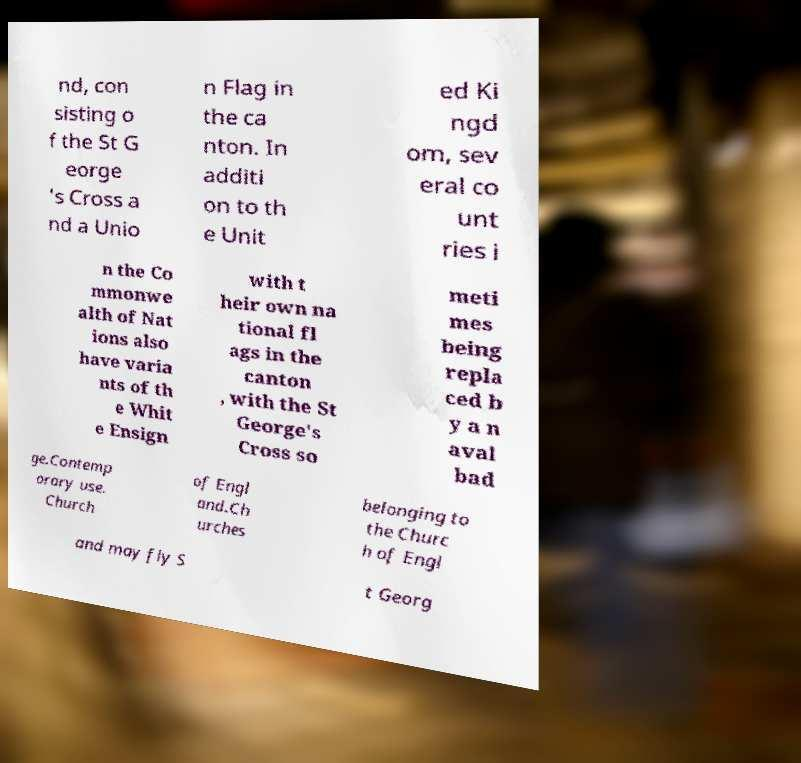I need the written content from this picture converted into text. Can you do that? nd, con sisting o f the St G eorge 's Cross a nd a Unio n Flag in the ca nton. In additi on to th e Unit ed Ki ngd om, sev eral co unt ries i n the Co mmonwe alth of Nat ions also have varia nts of th e Whit e Ensign with t heir own na tional fl ags in the canton , with the St George's Cross so meti mes being repla ced b y a n aval bad ge.Contemp orary use. Church of Engl and.Ch urches belonging to the Churc h of Engl and may fly S t Georg 